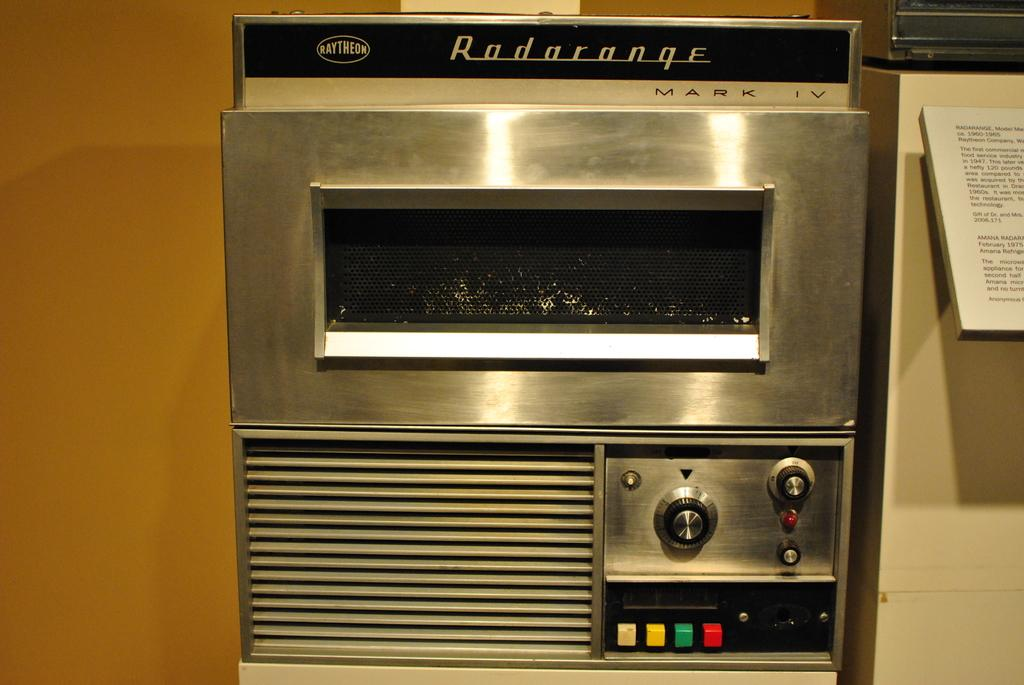<image>
Summarize the visual content of the image. A piece of electronic equipment is called Radarange Mark IV. 